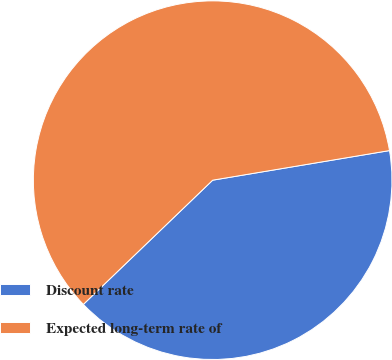Convert chart to OTSL. <chart><loc_0><loc_0><loc_500><loc_500><pie_chart><fcel>Discount rate<fcel>Expected long-term rate of<nl><fcel>40.46%<fcel>59.54%<nl></chart> 